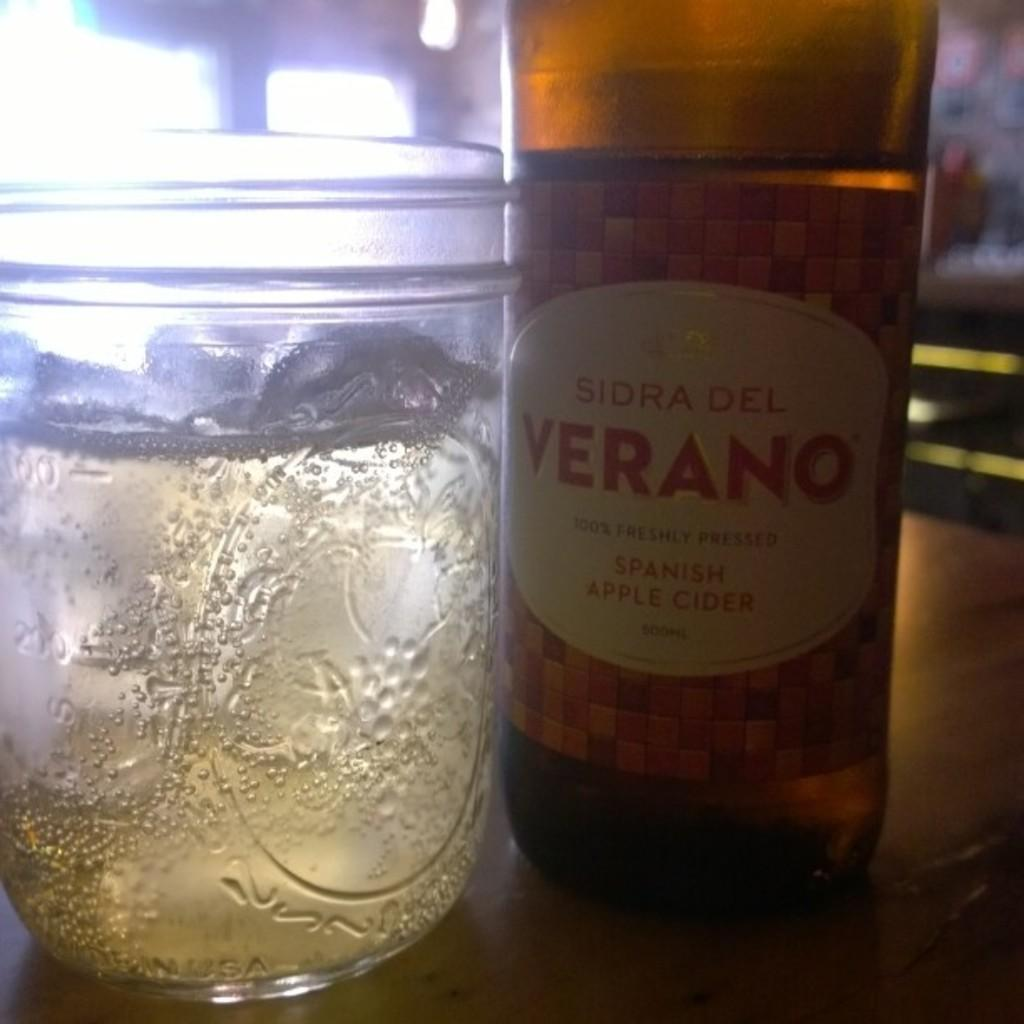<image>
Relay a brief, clear account of the picture shown. spanish apple cider bpttle and glass cup on the table 